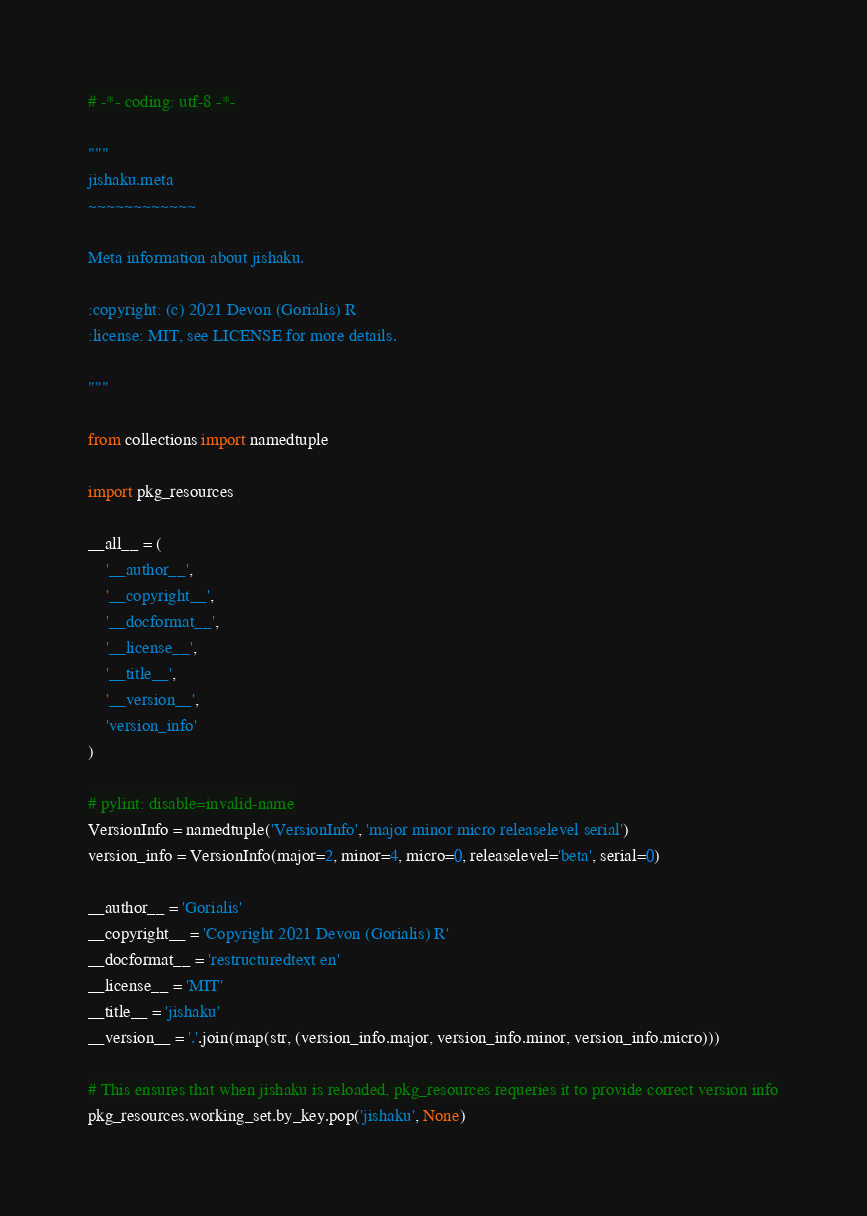<code> <loc_0><loc_0><loc_500><loc_500><_Python_># -*- coding: utf-8 -*-

"""
jishaku.meta
~~~~~~~~~~~~

Meta information about jishaku.

:copyright: (c) 2021 Devon (Gorialis) R
:license: MIT, see LICENSE for more details.

"""

from collections import namedtuple

import pkg_resources

__all__ = (
    '__author__',
    '__copyright__',
    '__docformat__',
    '__license__',
    '__title__',
    '__version__',
    'version_info'
)

# pylint: disable=invalid-name
VersionInfo = namedtuple('VersionInfo', 'major minor micro releaselevel serial')
version_info = VersionInfo(major=2, minor=4, micro=0, releaselevel='beta', serial=0)

__author__ = 'Gorialis'
__copyright__ = 'Copyright 2021 Devon (Gorialis) R'
__docformat__ = 'restructuredtext en'
__license__ = 'MIT'
__title__ = 'jishaku'
__version__ = '.'.join(map(str, (version_info.major, version_info.minor, version_info.micro)))

# This ensures that when jishaku is reloaded, pkg_resources requeries it to provide correct version info
pkg_resources.working_set.by_key.pop('jishaku', None)
</code> 